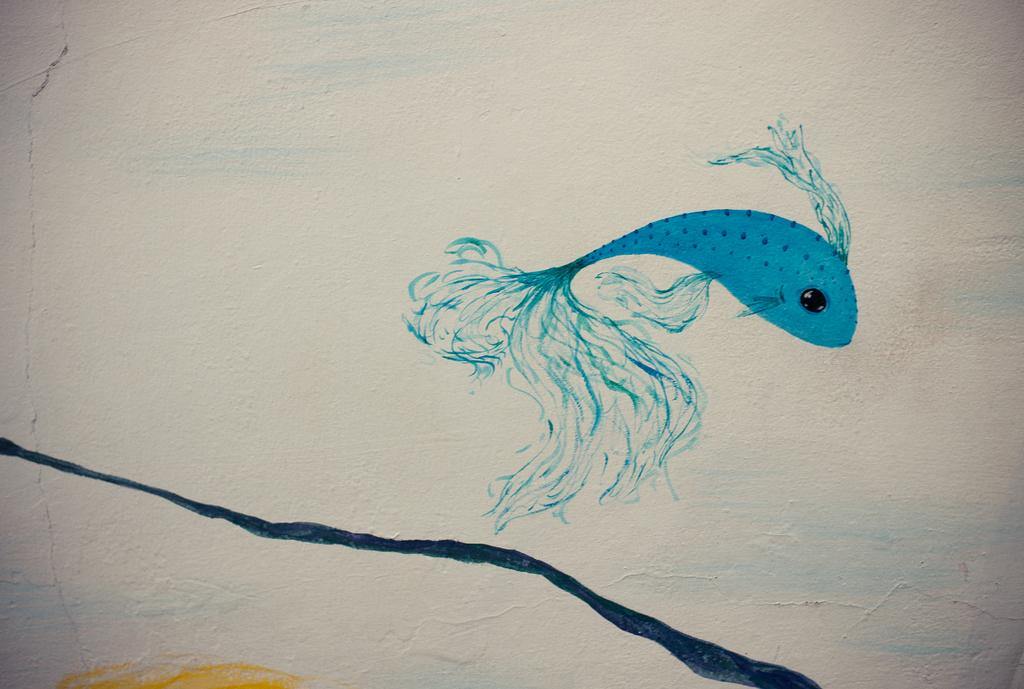What is the main subject of the image? The main subject of the image is an art of a fish. What color is the art of the fish? The art of the fish is in blue color. What colors are used in the background of the image? The background of the image is in white and yellow color. How many kittens are playing with a cork in the image? There are no kittens or cork present in the image; it features an art of a fish in blue color with a white and yellow background. What type of metal is used to create the art of the fish in the image? The image is a digital representation, so there is no metal used to create the art of the fish. 